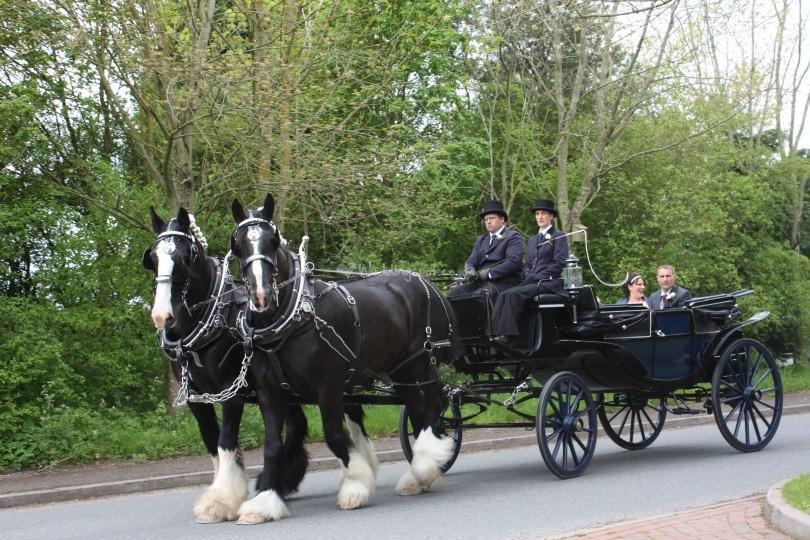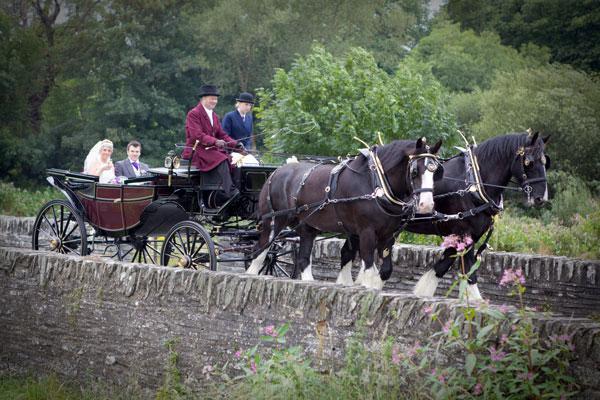The first image is the image on the left, the second image is the image on the right. For the images displayed, is the sentence "None of the wagons has more than a single person in the front seat." factually correct? Answer yes or no. No. The first image is the image on the left, the second image is the image on the right. Considering the images on both sides, is "The horse carriage are facing opposite directions from each other." valid? Answer yes or no. Yes. 